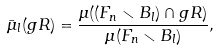<formula> <loc_0><loc_0><loc_500><loc_500>\bar { \mu } _ { l } ( g R ) = \frac { \mu ( ( F _ { n } \smallsetminus B _ { l } ) \cap g R ) } { \mu ( F _ { n } \smallsetminus B _ { l } ) } ,</formula> 